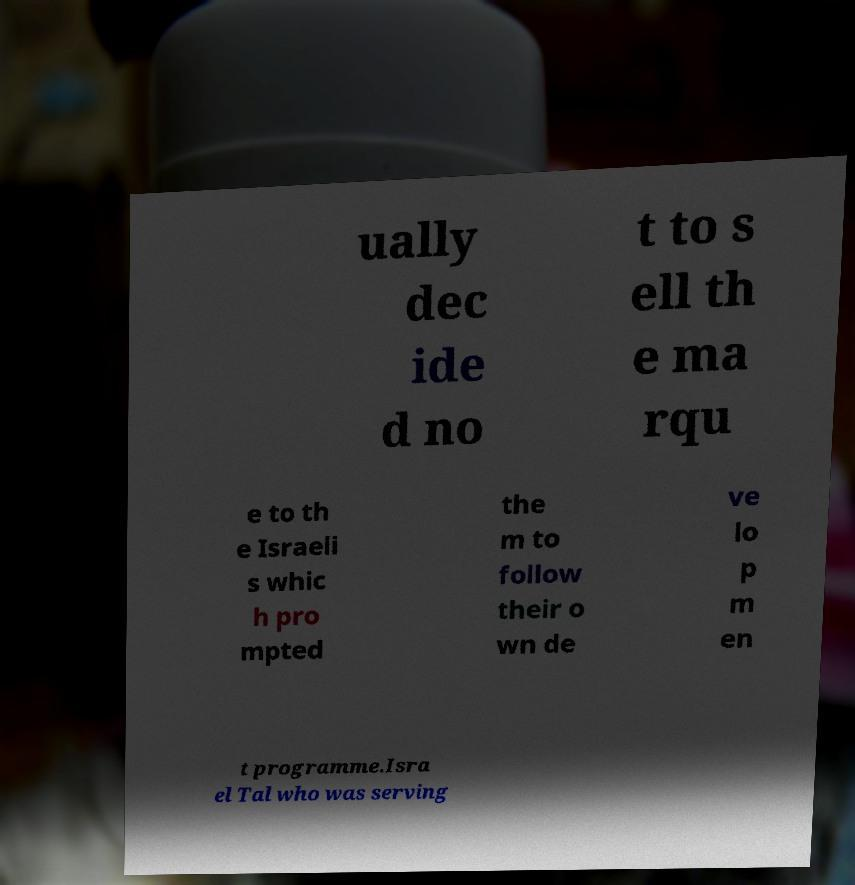Can you read and provide the text displayed in the image?This photo seems to have some interesting text. Can you extract and type it out for me? ually dec ide d no t to s ell th e ma rqu e to th e Israeli s whic h pro mpted the m to follow their o wn de ve lo p m en t programme.Isra el Tal who was serving 